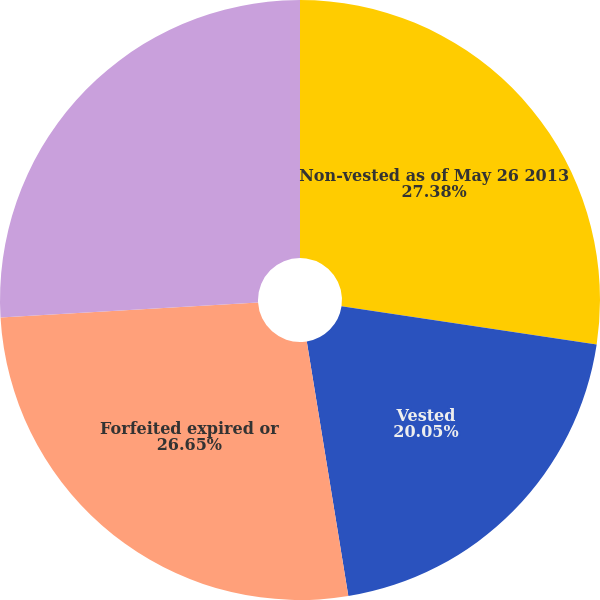Convert chart to OTSL. <chart><loc_0><loc_0><loc_500><loc_500><pie_chart><fcel>Non-vested as of May 26 2013<fcel>Vested<fcel>Forfeited expired or<fcel>Non-vested as of May 25 2014<nl><fcel>27.37%<fcel>20.05%<fcel>26.65%<fcel>25.92%<nl></chart> 